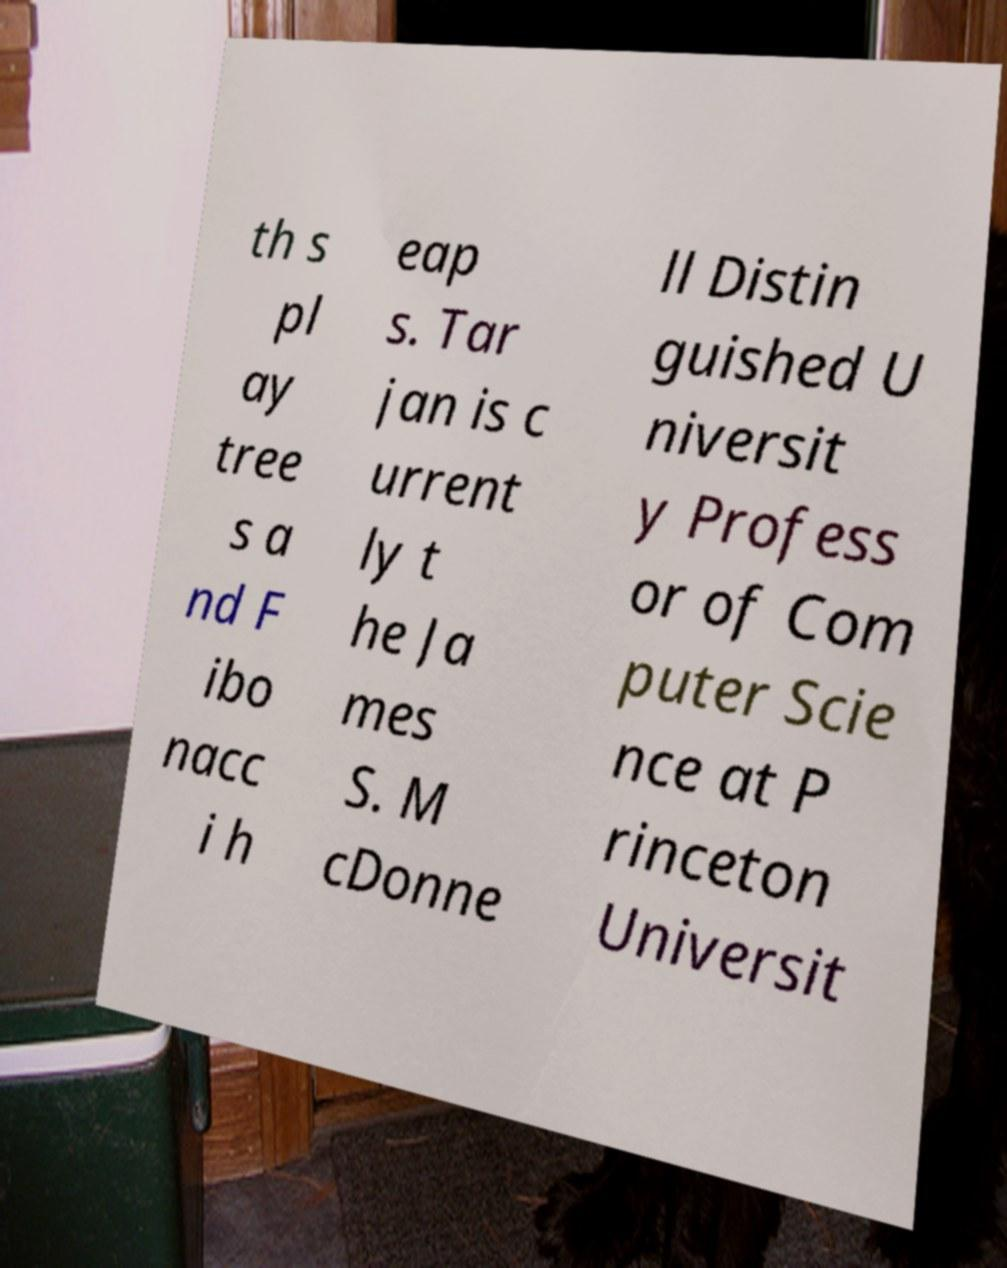I need the written content from this picture converted into text. Can you do that? th s pl ay tree s a nd F ibo nacc i h eap s. Tar jan is c urrent ly t he Ja mes S. M cDonne ll Distin guished U niversit y Profess or of Com puter Scie nce at P rinceton Universit 